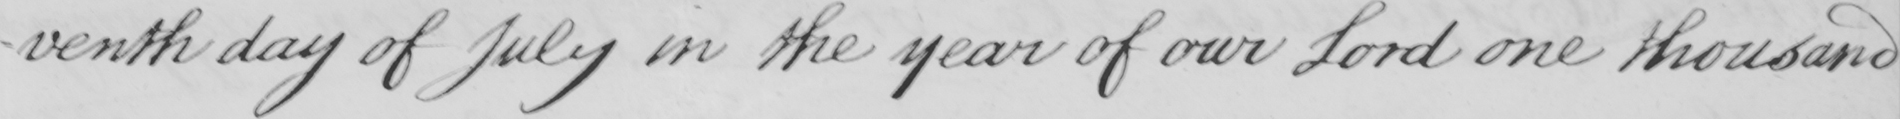What does this handwritten line say? -venth day of July in the year of our Lord one thousand 